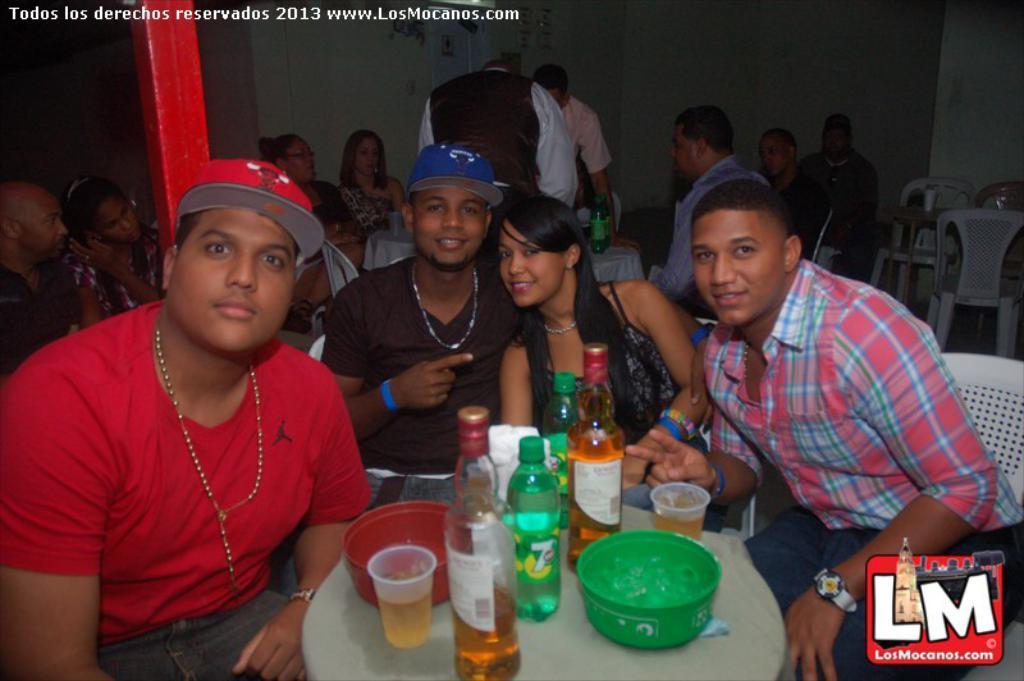How would you summarize this image in a sentence or two? In this image few persons are sitting on a chair before a table having few bottles, glasses and bowls on it. A person is wearing a red shirt is wearing a red colour cap. A person wearing a black dress is wearing a blue colour cap. Behind them two persons are standing and few persons are sitting on the chair. There is a table having bottles on it. Behind them there is a wall. Right side there is a table having few chairs around it. 